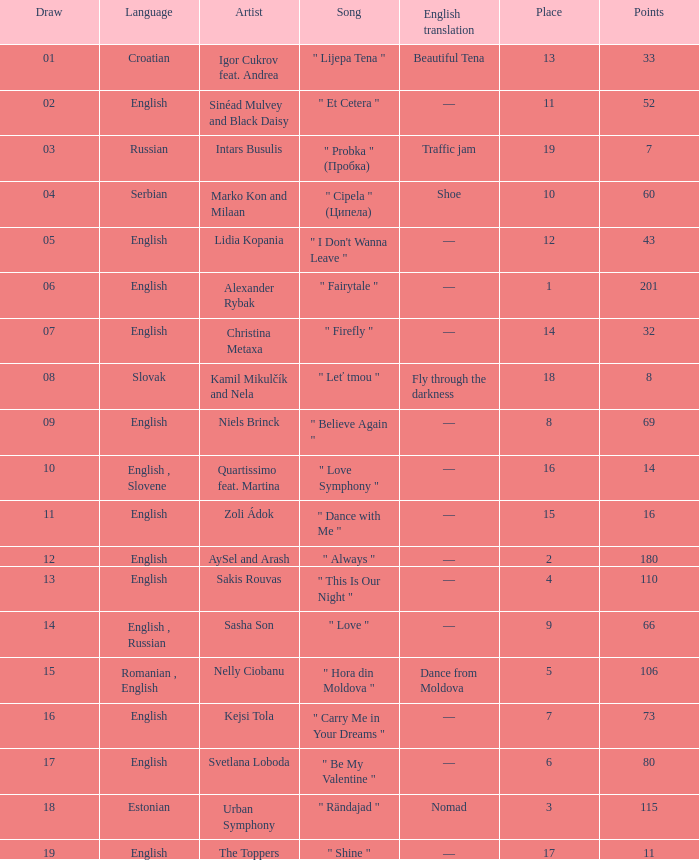What is the average Points when the artist is kamil mikulčík and nela, and the Place is larger than 18? None. 